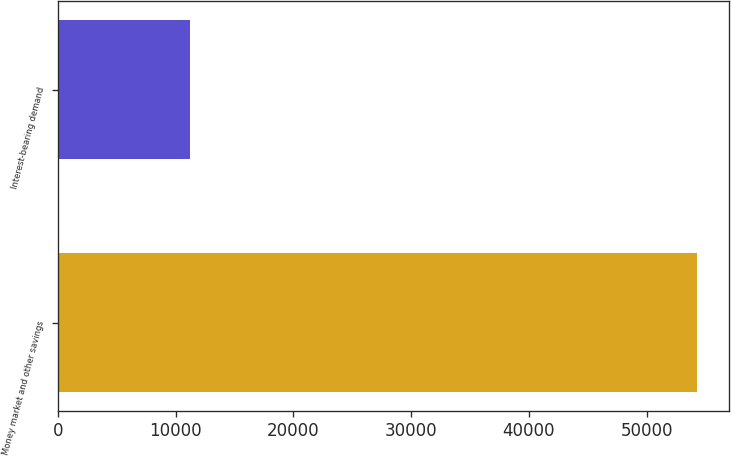Convert chart. <chart><loc_0><loc_0><loc_500><loc_500><bar_chart><fcel>Money market and other savings<fcel>Interest-bearing demand<nl><fcel>54318<fcel>11227<nl></chart> 